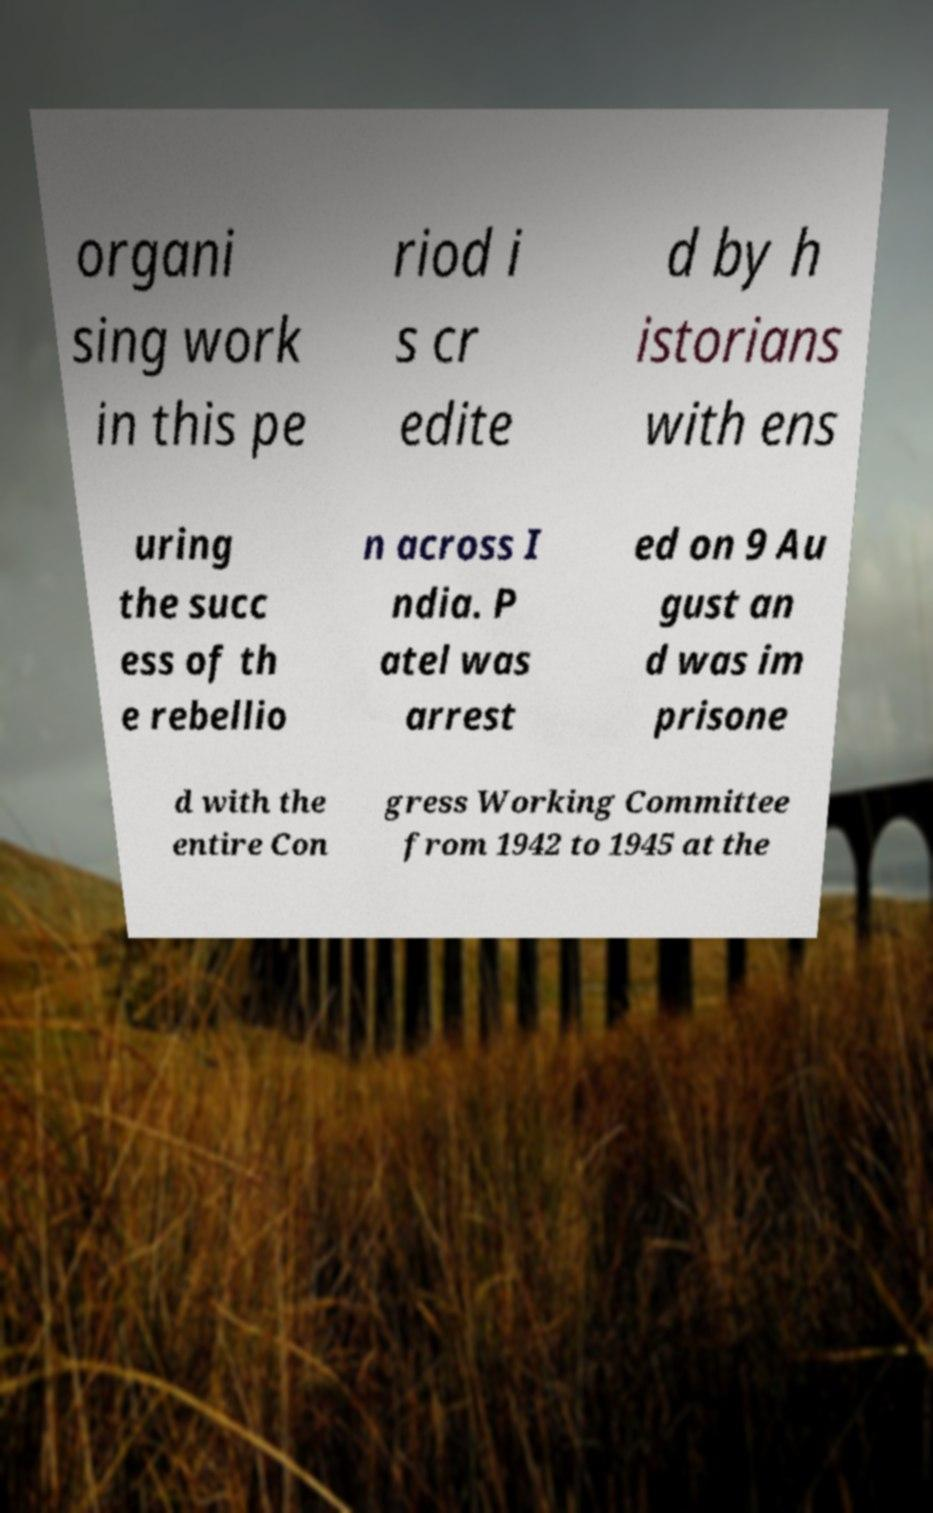I need the written content from this picture converted into text. Can you do that? organi sing work in this pe riod i s cr edite d by h istorians with ens uring the succ ess of th e rebellio n across I ndia. P atel was arrest ed on 9 Au gust an d was im prisone d with the entire Con gress Working Committee from 1942 to 1945 at the 